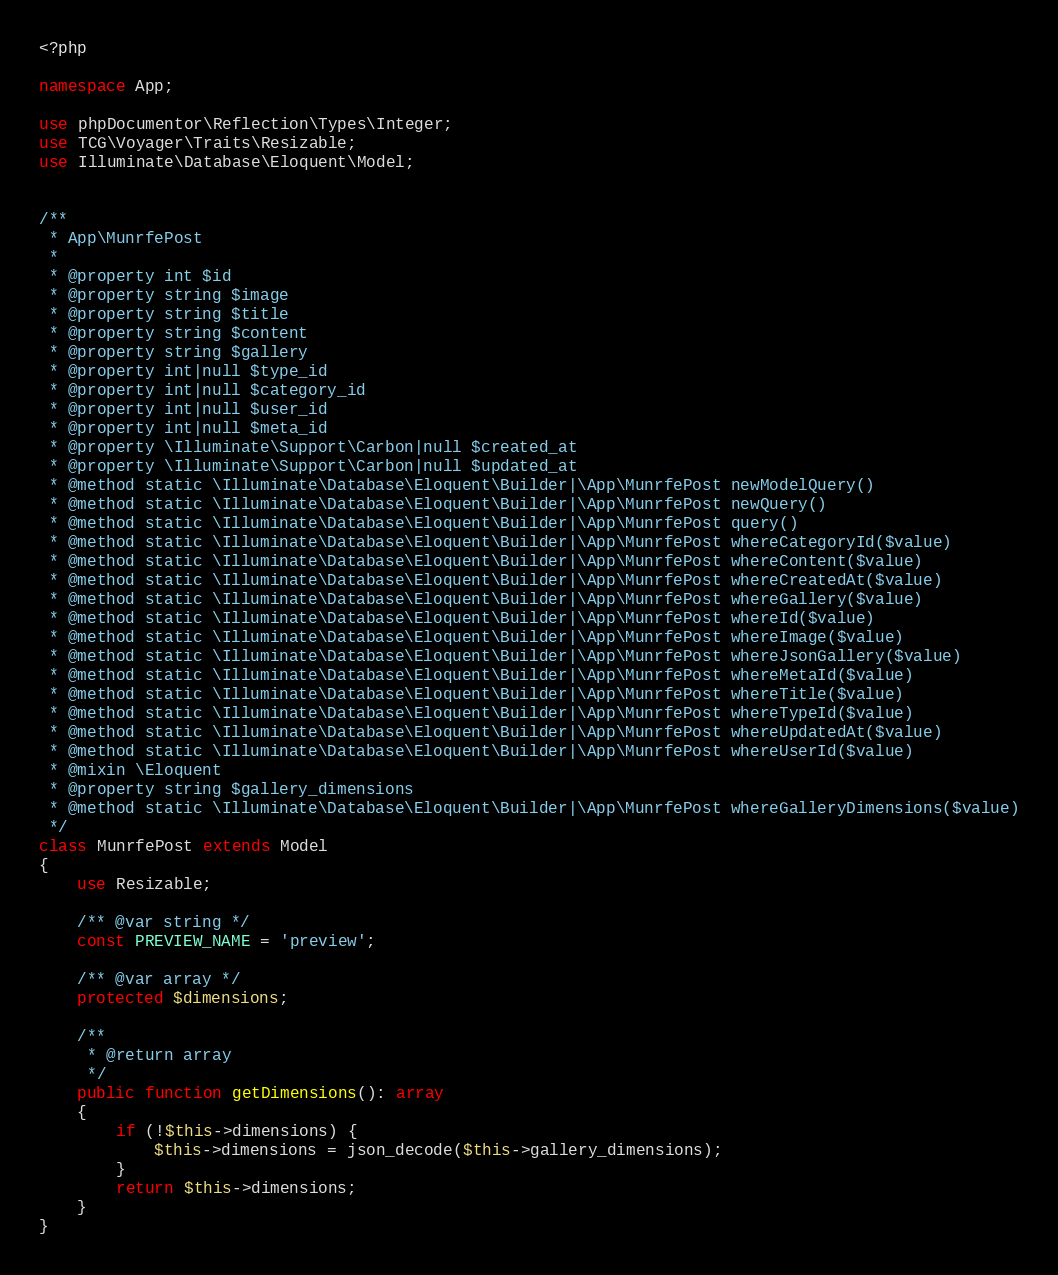Convert code to text. <code><loc_0><loc_0><loc_500><loc_500><_PHP_><?php

namespace App;

use phpDocumentor\Reflection\Types\Integer;
use TCG\Voyager\Traits\Resizable;
use Illuminate\Database\Eloquent\Model;


/**
 * App\MunrfePost
 *
 * @property int $id
 * @property string $image
 * @property string $title
 * @property string $content
 * @property string $gallery
 * @property int|null $type_id
 * @property int|null $category_id
 * @property int|null $user_id
 * @property int|null $meta_id
 * @property \Illuminate\Support\Carbon|null $created_at
 * @property \Illuminate\Support\Carbon|null $updated_at
 * @method static \Illuminate\Database\Eloquent\Builder|\App\MunrfePost newModelQuery()
 * @method static \Illuminate\Database\Eloquent\Builder|\App\MunrfePost newQuery()
 * @method static \Illuminate\Database\Eloquent\Builder|\App\MunrfePost query()
 * @method static \Illuminate\Database\Eloquent\Builder|\App\MunrfePost whereCategoryId($value)
 * @method static \Illuminate\Database\Eloquent\Builder|\App\MunrfePost whereContent($value)
 * @method static \Illuminate\Database\Eloquent\Builder|\App\MunrfePost whereCreatedAt($value)
 * @method static \Illuminate\Database\Eloquent\Builder|\App\MunrfePost whereGallery($value)
 * @method static \Illuminate\Database\Eloquent\Builder|\App\MunrfePost whereId($value)
 * @method static \Illuminate\Database\Eloquent\Builder|\App\MunrfePost whereImage($value)
 * @method static \Illuminate\Database\Eloquent\Builder|\App\MunrfePost whereJsonGallery($value)
 * @method static \Illuminate\Database\Eloquent\Builder|\App\MunrfePost whereMetaId($value)
 * @method static \Illuminate\Database\Eloquent\Builder|\App\MunrfePost whereTitle($value)
 * @method static \Illuminate\Database\Eloquent\Builder|\App\MunrfePost whereTypeId($value)
 * @method static \Illuminate\Database\Eloquent\Builder|\App\MunrfePost whereUpdatedAt($value)
 * @method static \Illuminate\Database\Eloquent\Builder|\App\MunrfePost whereUserId($value)
 * @mixin \Eloquent
 * @property string $gallery_dimensions
 * @method static \Illuminate\Database\Eloquent\Builder|\App\MunrfePost whereGalleryDimensions($value)
 */
class MunrfePost extends Model
{
    use Resizable;

    /** @var string */
    const PREVIEW_NAME = 'preview';

    /** @var array */
    protected $dimensions;

    /**
     * @return array
     */
    public function getDimensions(): array
    {
        if (!$this->dimensions) {
            $this->dimensions = json_decode($this->gallery_dimensions);
        }
        return $this->dimensions;
    }
}
</code> 